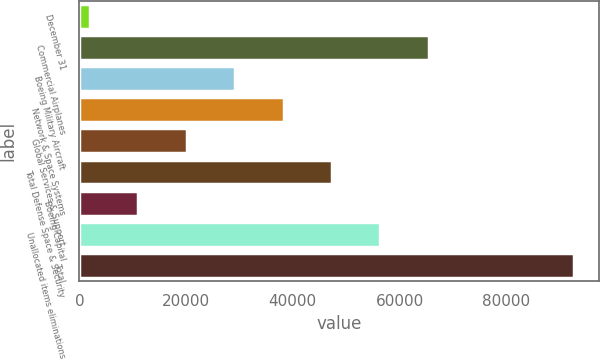Convert chart to OTSL. <chart><loc_0><loc_0><loc_500><loc_500><bar_chart><fcel>December 31<fcel>Commercial Airplanes<fcel>Boeing Military Aircraft<fcel>Network & Space Systems<fcel>Global Services & Support<fcel>Total Defense Space & Security<fcel>Boeing Capital<fcel>Unallocated items eliminations<fcel>Total<nl><fcel>2013<fcel>65468<fcel>29208<fcel>38273<fcel>20143<fcel>47338<fcel>11078<fcel>56403<fcel>92663<nl></chart> 